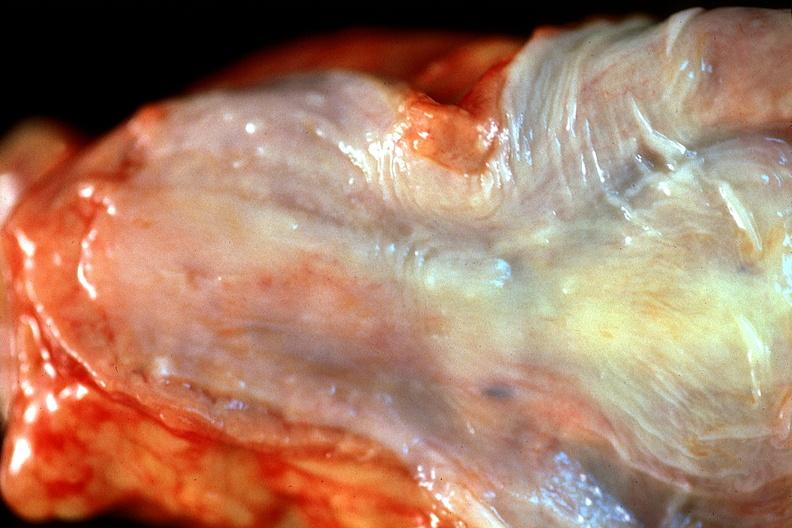what is present?
Answer the question using a single word or phrase. Gastrointestinal 